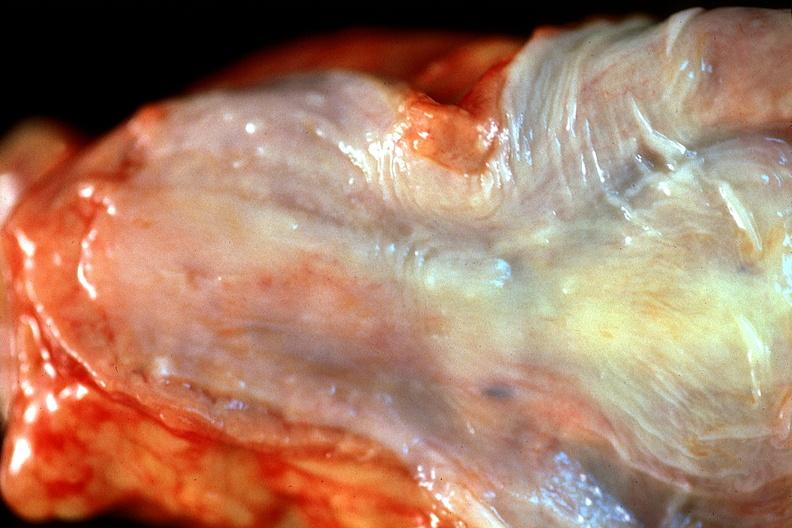what is present?
Answer the question using a single word or phrase. Gastrointestinal 